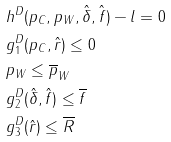Convert formula to latex. <formula><loc_0><loc_0><loc_500><loc_500>& h ^ { D } ( p _ { C } , p _ { W } , \hat { \delta } , \hat { f } ) - l = 0 \\ & g _ { 1 } ^ { D } ( p _ { C } , \hat { r } ) \leq 0 \\ & p _ { W } \leq \overline { p } _ { W } \\ & g _ { 2 } ^ { D } ( \hat { \delta } , \hat { f } ) \leq \overline { f } \\ & g _ { 3 } ^ { D } ( \hat { r } ) \leq \overline { R }</formula> 